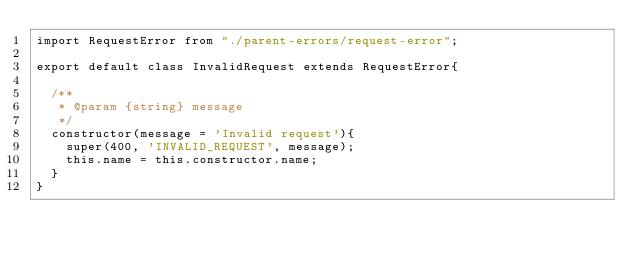Convert code to text. <code><loc_0><loc_0><loc_500><loc_500><_JavaScript_>import RequestError from "./parent-errors/request-error";

export default class InvalidRequest extends RequestError{

	/**
	 * @param {string} message 
	 */
	constructor(message = 'Invalid request'){
		super(400, 'INVALID_REQUEST', message);
		this.name = this.constructor.name; 
	}
}</code> 